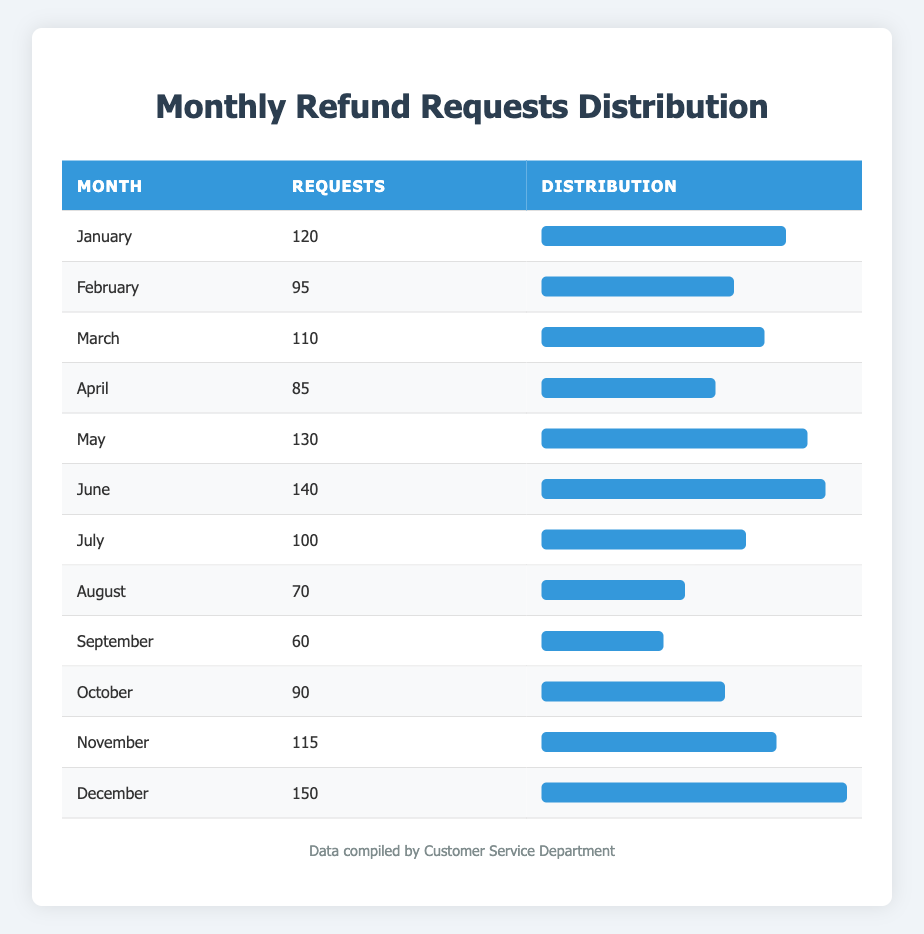What is the total number of refund requests made in June? The table shows that June has 140 refund requests listed for that month.
Answer: 140 Which month had the highest number of refund requests? By examining the table, December has 150 refund requests, the highest compared to other months listed.
Answer: December What is the average number of refund requests from January to July? To calculate the average, we first sum the requests from January (120), February (95), March (110), April (85), May (130), June (140), and July (100). The total is 120 + 95 + 110 + 85 + 130 + 140 + 100 = 980. There are 7 months, so the average is 980 / 7 = 140.
Answer: 140 Did the number of refund requests in August exceed 80? The table states that August has 70 requests, which is less than 80.
Answer: No Which month had a smaller number of requests: April or September? April has 85 refund requests while September has 60. Since 60 is less than 85, September had the smaller number of requests.
Answer: September What is the difference in refund requests between June and November? June has 140 requests, and November has 115 requests. The difference is 140 - 115 = 25, indicating June had 25 more requests than November.
Answer: 25 If we combine the requests from May and June, what is the total? May has 130 requests and June has 140 requests. By adding these two figures, the total becomes 130 + 140 = 270.
Answer: 270 Is it true that July had more refund requests than February? The table reveals that July had 100 requests while February had 95. Therefore, July indeed had more requests than February.
Answer: Yes What percentage of the total refund requests for the year were made in December? First, sum all the refund requests for each month: 120 + 95 + 110 + 85 + 130 + 140 + 100 + 70 + 60 + 90 + 115 + 150 = 1,350. December's requests are 150. The percentage is (150 / 1350) * 100 = 11.11%.
Answer: 11.11% 